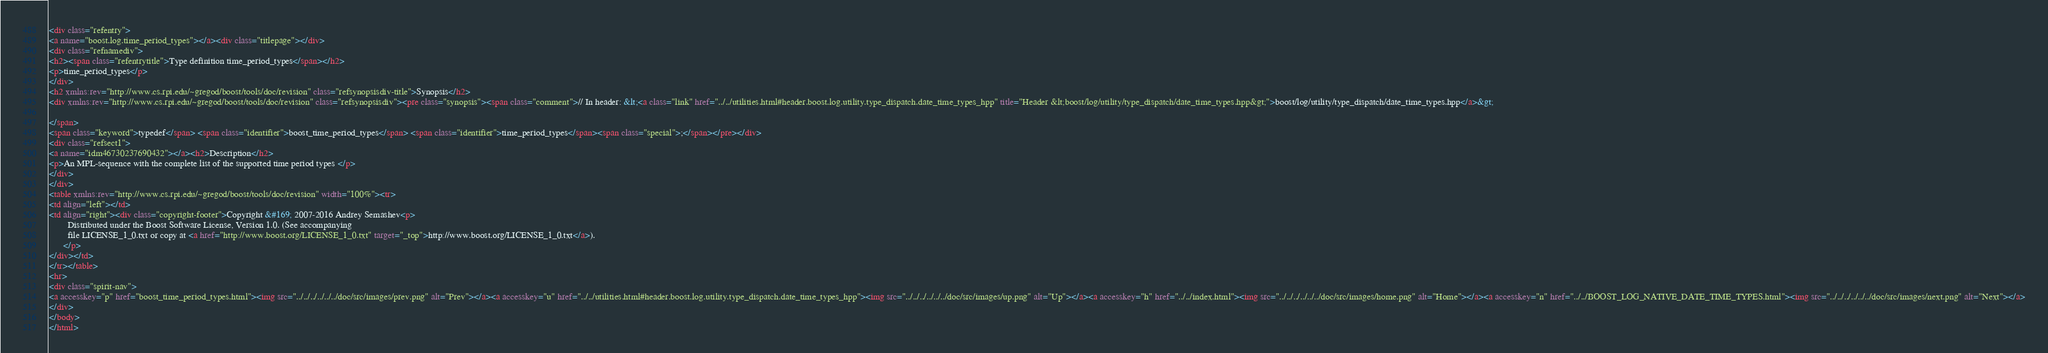Convert code to text. <code><loc_0><loc_0><loc_500><loc_500><_HTML_><div class="refentry">
<a name="boost.log.time_period_types"></a><div class="titlepage"></div>
<div class="refnamediv">
<h2><span class="refentrytitle">Type definition time_period_types</span></h2>
<p>time_period_types</p>
</div>
<h2 xmlns:rev="http://www.cs.rpi.edu/~gregod/boost/tools/doc/revision" class="refsynopsisdiv-title">Synopsis</h2>
<div xmlns:rev="http://www.cs.rpi.edu/~gregod/boost/tools/doc/revision" class="refsynopsisdiv"><pre class="synopsis"><span class="comment">// In header: &lt;<a class="link" href="../../utilities.html#header.boost.log.utility.type_dispatch.date_time_types_hpp" title="Header &lt;boost/log/utility/type_dispatch/date_time_types.hpp&gt;">boost/log/utility/type_dispatch/date_time_types.hpp</a>&gt;

</span>
<span class="keyword">typedef</span> <span class="identifier">boost_time_period_types</span> <span class="identifier">time_period_types</span><span class="special">;</span></pre></div>
<div class="refsect1">
<a name="idm46730237690432"></a><h2>Description</h2>
<p>An MPL-sequence with the complete list of the supported time period types </p>
</div>
</div>
<table xmlns:rev="http://www.cs.rpi.edu/~gregod/boost/tools/doc/revision" width="100%"><tr>
<td align="left"></td>
<td align="right"><div class="copyright-footer">Copyright &#169; 2007-2016 Andrey Semashev<p>
        Distributed under the Boost Software License, Version 1.0. (See accompanying
        file LICENSE_1_0.txt or copy at <a href="http://www.boost.org/LICENSE_1_0.txt" target="_top">http://www.boost.org/LICENSE_1_0.txt</a>).
      </p>
</div></td>
</tr></table>
<hr>
<div class="spirit-nav">
<a accesskey="p" href="boost_time_period_types.html"><img src="../../../../../../doc/src/images/prev.png" alt="Prev"></a><a accesskey="u" href="../../utilities.html#header.boost.log.utility.type_dispatch.date_time_types_hpp"><img src="../../../../../../doc/src/images/up.png" alt="Up"></a><a accesskey="h" href="../../index.html"><img src="../../../../../../doc/src/images/home.png" alt="Home"></a><a accesskey="n" href="../../BOOST_LOG_NATIVE_DATE_TIME_TYPES.html"><img src="../../../../../../doc/src/images/next.png" alt="Next"></a>
</div>
</body>
</html>
</code> 